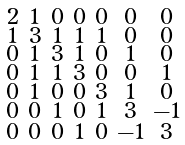<formula> <loc_0><loc_0><loc_500><loc_500>\begin{smallmatrix} 2 & 1 & 0 & 0 & 0 & 0 & 0 \\ 1 & 3 & 1 & 1 & 1 & 0 & 0 \\ 0 & 1 & 3 & 1 & 0 & 1 & 0 \\ 0 & 1 & 1 & 3 & 0 & 0 & 1 \\ 0 & 1 & 0 & 0 & 3 & 1 & 0 \\ 0 & 0 & 1 & 0 & 1 & 3 & - 1 \\ 0 & 0 & 0 & 1 & 0 & - 1 & 3 \end{smallmatrix}</formula> 